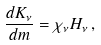Convert formula to latex. <formula><loc_0><loc_0><loc_500><loc_500>\frac { d K _ { \nu } } { d m } = \chi _ { \nu } H _ { \nu } \, ,</formula> 